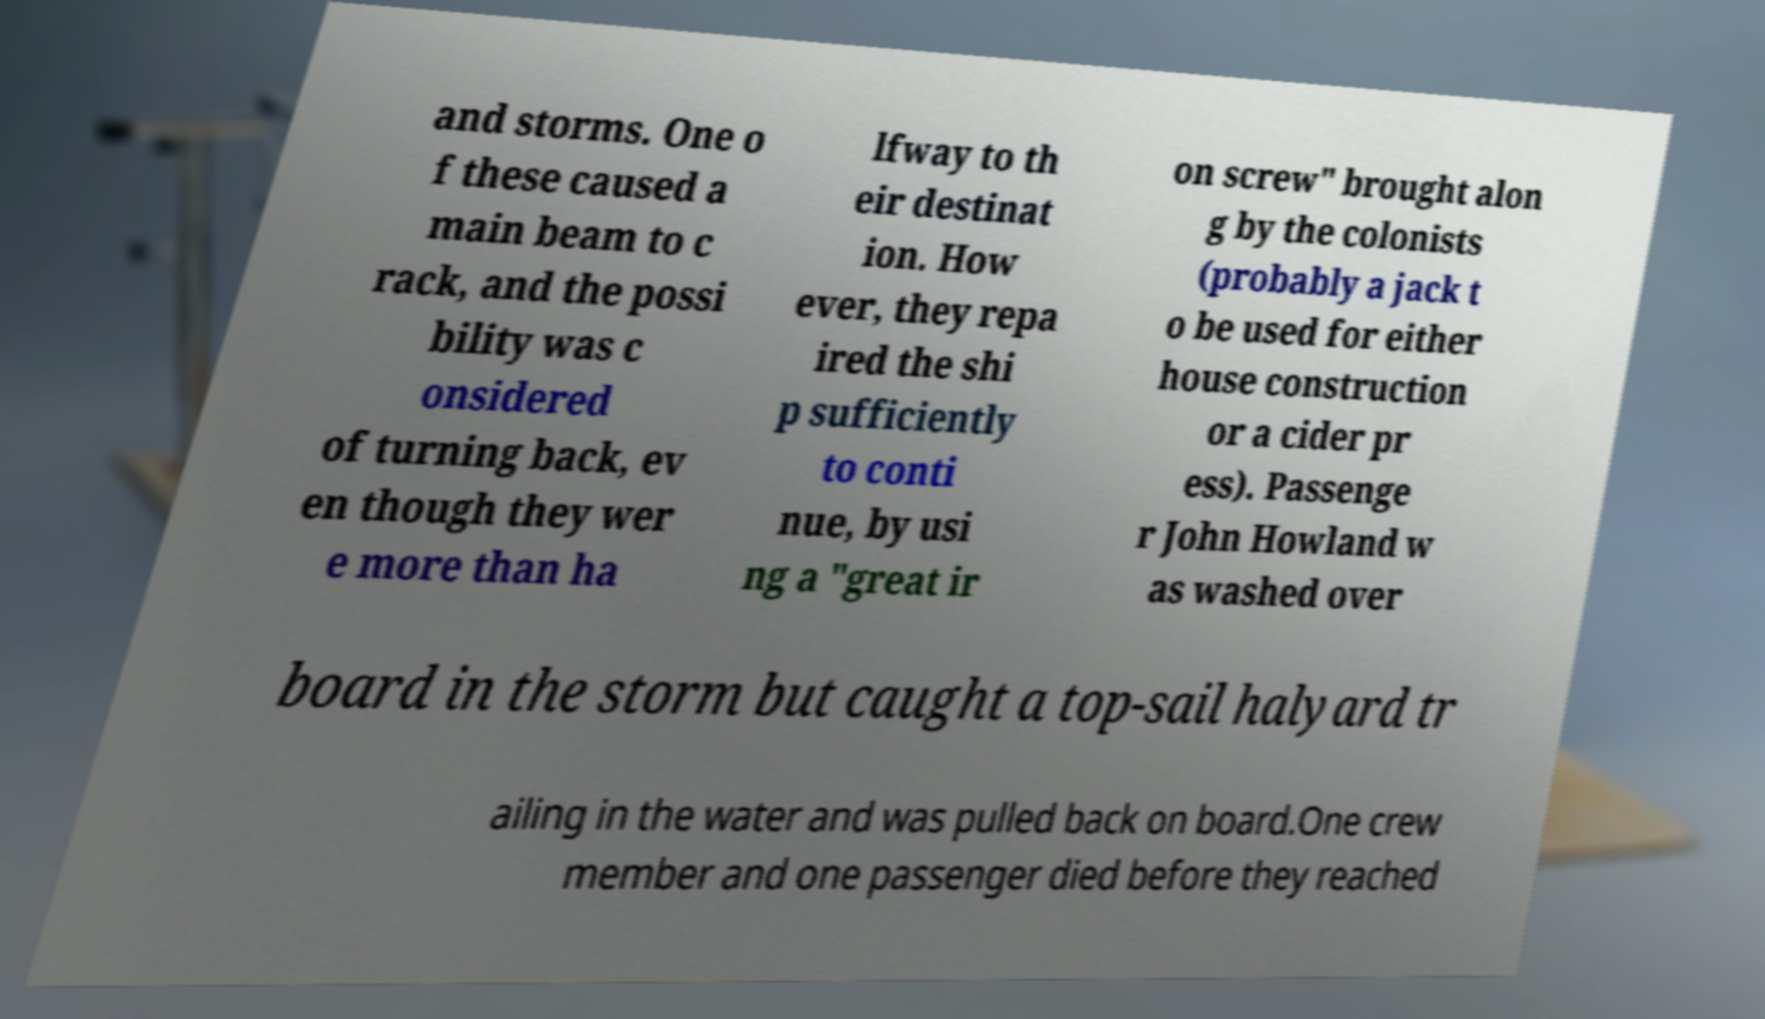Can you accurately transcribe the text from the provided image for me? and storms. One o f these caused a main beam to c rack, and the possi bility was c onsidered of turning back, ev en though they wer e more than ha lfway to th eir destinat ion. How ever, they repa ired the shi p sufficiently to conti nue, by usi ng a "great ir on screw" brought alon g by the colonists (probably a jack t o be used for either house construction or a cider pr ess). Passenge r John Howland w as washed over board in the storm but caught a top-sail halyard tr ailing in the water and was pulled back on board.One crew member and one passenger died before they reached 